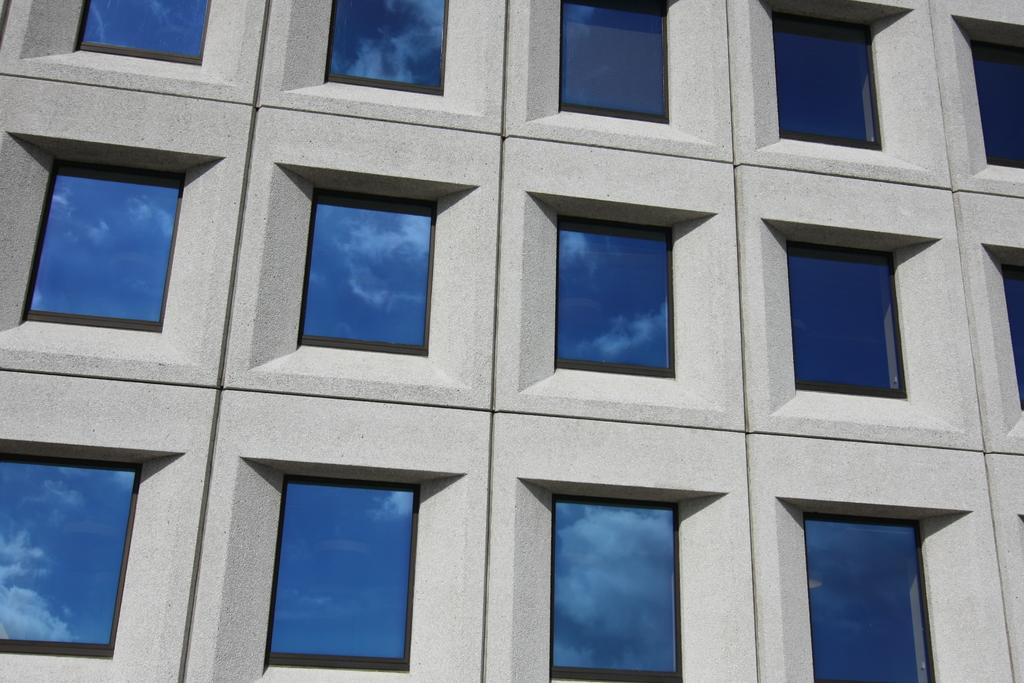What is the main structure in the image? There is a building in the image. What feature can be seen on the building? The building has windows. What can be observed in the windows? The sky is reflected in the windows. What type of drink is being served in the windows of the building? There is no drink present in the windows of the building; the windows are reflecting the sky. 